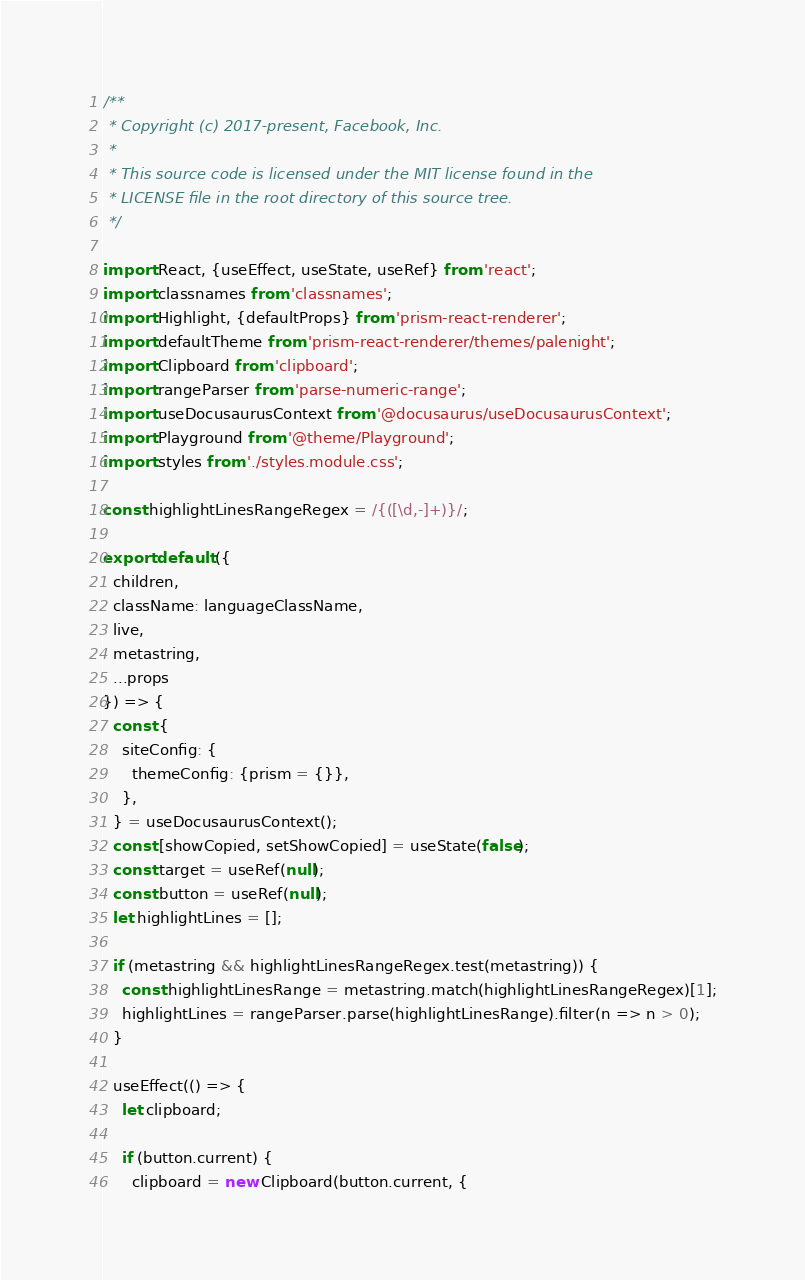Convert code to text. <code><loc_0><loc_0><loc_500><loc_500><_JavaScript_>/**
 * Copyright (c) 2017-present, Facebook, Inc.
 *
 * This source code is licensed under the MIT license found in the
 * LICENSE file in the root directory of this source tree.
 */

import React, {useEffect, useState, useRef} from 'react';
import classnames from 'classnames';
import Highlight, {defaultProps} from 'prism-react-renderer';
import defaultTheme from 'prism-react-renderer/themes/palenight';
import Clipboard from 'clipboard';
import rangeParser from 'parse-numeric-range';
import useDocusaurusContext from '@docusaurus/useDocusaurusContext';
import Playground from '@theme/Playground';
import styles from './styles.module.css';

const highlightLinesRangeRegex = /{([\d,-]+)}/;

export default ({
  children,
  className: languageClassName,
  live,
  metastring,
  ...props
}) => {
  const {
    siteConfig: {
      themeConfig: {prism = {}},
    },
  } = useDocusaurusContext();
  const [showCopied, setShowCopied] = useState(false);
  const target = useRef(null);
  const button = useRef(null);
  let highlightLines = [];

  if (metastring && highlightLinesRangeRegex.test(metastring)) {
    const highlightLinesRange = metastring.match(highlightLinesRangeRegex)[1];
    highlightLines = rangeParser.parse(highlightLinesRange).filter(n => n > 0);
  }

  useEffect(() => {
    let clipboard;

    if (button.current) {
      clipboard = new Clipboard(button.current, {</code> 